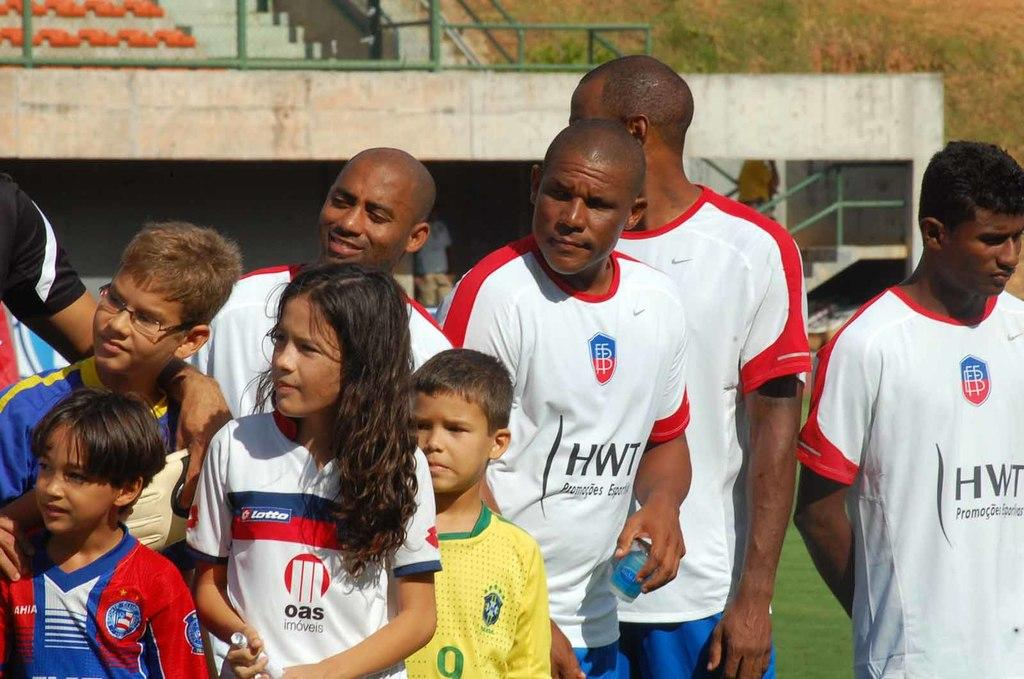<image>
Give a short and clear explanation of the subsequent image. People wear shirts with HWT logos on them. 